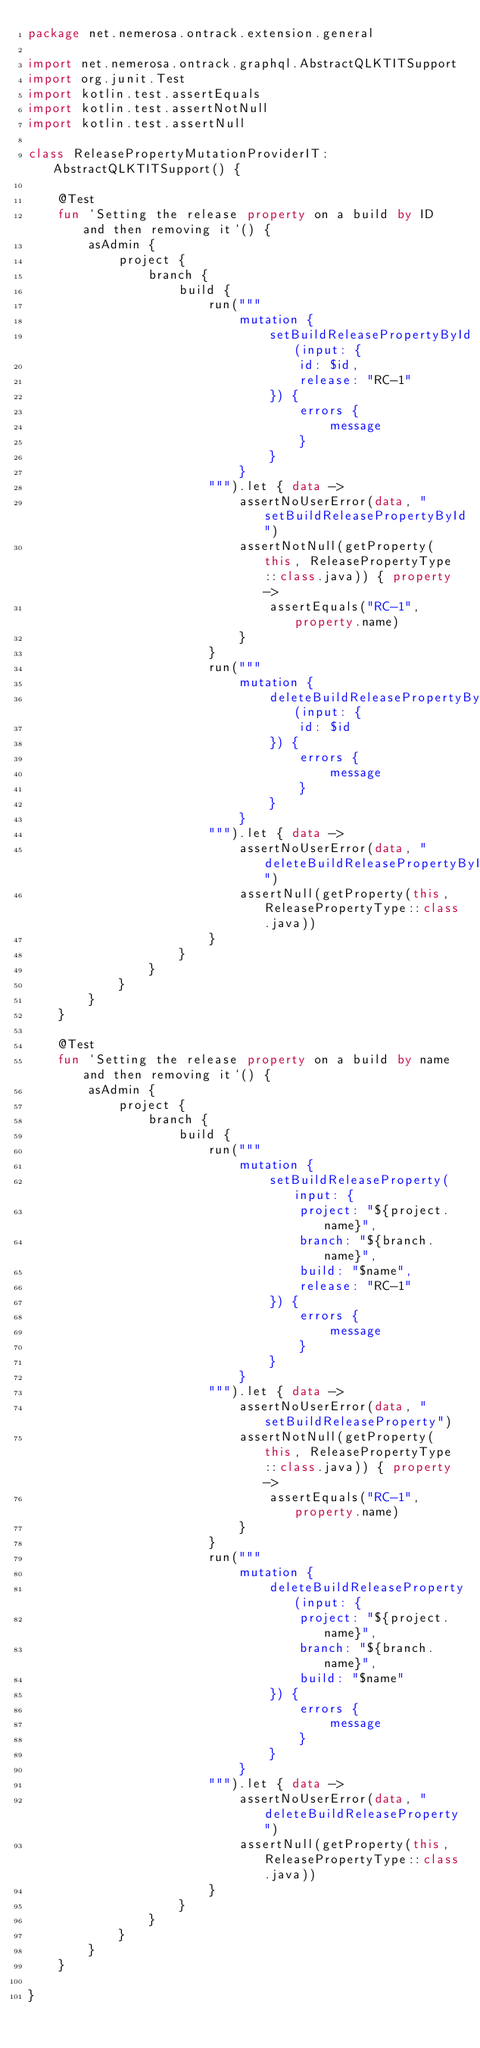Convert code to text. <code><loc_0><loc_0><loc_500><loc_500><_Kotlin_>package net.nemerosa.ontrack.extension.general

import net.nemerosa.ontrack.graphql.AbstractQLKTITSupport
import org.junit.Test
import kotlin.test.assertEquals
import kotlin.test.assertNotNull
import kotlin.test.assertNull

class ReleasePropertyMutationProviderIT: AbstractQLKTITSupport() {

    @Test
    fun `Setting the release property on a build by ID and then removing it`() {
        asAdmin {
            project {
                branch {
                    build {
                        run("""
                            mutation {
                                setBuildReleasePropertyById(input: {
                                    id: $id,
                                    release: "RC-1"
                                }) {
                                    errors {
                                        message
                                    }
                                }
                            }
                        """).let { data ->
                            assertNoUserError(data, "setBuildReleasePropertyById")
                            assertNotNull(getProperty(this, ReleasePropertyType::class.java)) { property ->
                                assertEquals("RC-1", property.name)
                            }
                        }
                        run("""
                            mutation {
                                deleteBuildReleasePropertyById(input: {
                                    id: $id
                                }) {
                                    errors {
                                        message
                                    }
                                }
                            }
                        """).let { data ->
                            assertNoUserError(data, "deleteBuildReleasePropertyById")
                            assertNull(getProperty(this, ReleasePropertyType::class.java))
                        }
                    }
                }
            }
        }
    }

    @Test
    fun `Setting the release property on a build by name and then removing it`() {
        asAdmin {
            project {
                branch {
                    build {
                        run("""
                            mutation {
                                setBuildReleaseProperty(input: {
                                    project: "${project.name}",
                                    branch: "${branch.name}",
                                    build: "$name",
                                    release: "RC-1"
                                }) {
                                    errors {
                                        message
                                    }
                                }
                            }
                        """).let { data ->
                            assertNoUserError(data, "setBuildReleaseProperty")
                            assertNotNull(getProperty(this, ReleasePropertyType::class.java)) { property ->
                                assertEquals("RC-1", property.name)
                            }
                        }
                        run("""
                            mutation {
                                deleteBuildReleaseProperty(input: {
                                    project: "${project.name}",
                                    branch: "${branch.name}",
                                    build: "$name"
                                }) {
                                    errors {
                                        message
                                    }
                                }
                            }
                        """).let { data ->
                            assertNoUserError(data, "deleteBuildReleaseProperty")
                            assertNull(getProperty(this, ReleasePropertyType::class.java))
                        }
                    }
                }
            }
        }
    }

}</code> 